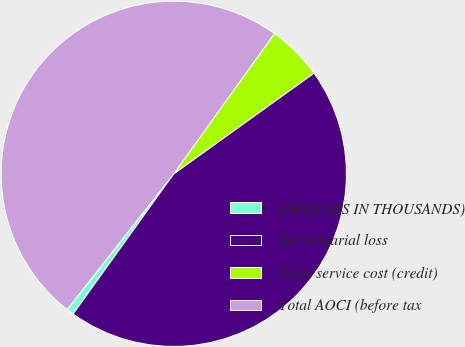Convert chart to OTSL. <chart><loc_0><loc_0><loc_500><loc_500><pie_chart><fcel>(DOLLARS IN THOUSANDS)<fcel>Net actuarial loss<fcel>Prior service cost (credit)<fcel>Total AOCI (before tax<nl><fcel>0.69%<fcel>44.82%<fcel>5.18%<fcel>49.31%<nl></chart> 